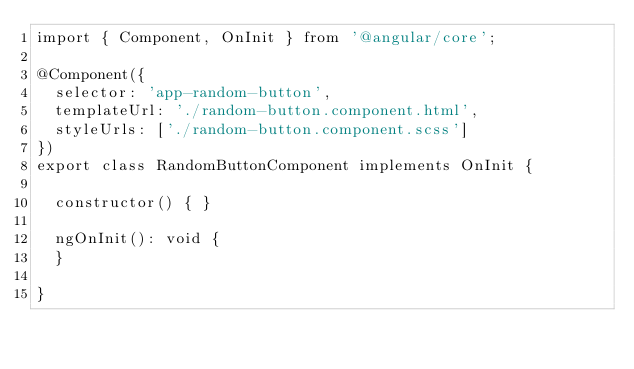Convert code to text. <code><loc_0><loc_0><loc_500><loc_500><_TypeScript_>import { Component, OnInit } from '@angular/core';

@Component({
  selector: 'app-random-button',
  templateUrl: './random-button.component.html',
  styleUrls: ['./random-button.component.scss']
})
export class RandomButtonComponent implements OnInit {

  constructor() { }

  ngOnInit(): void {
  }

}
</code> 